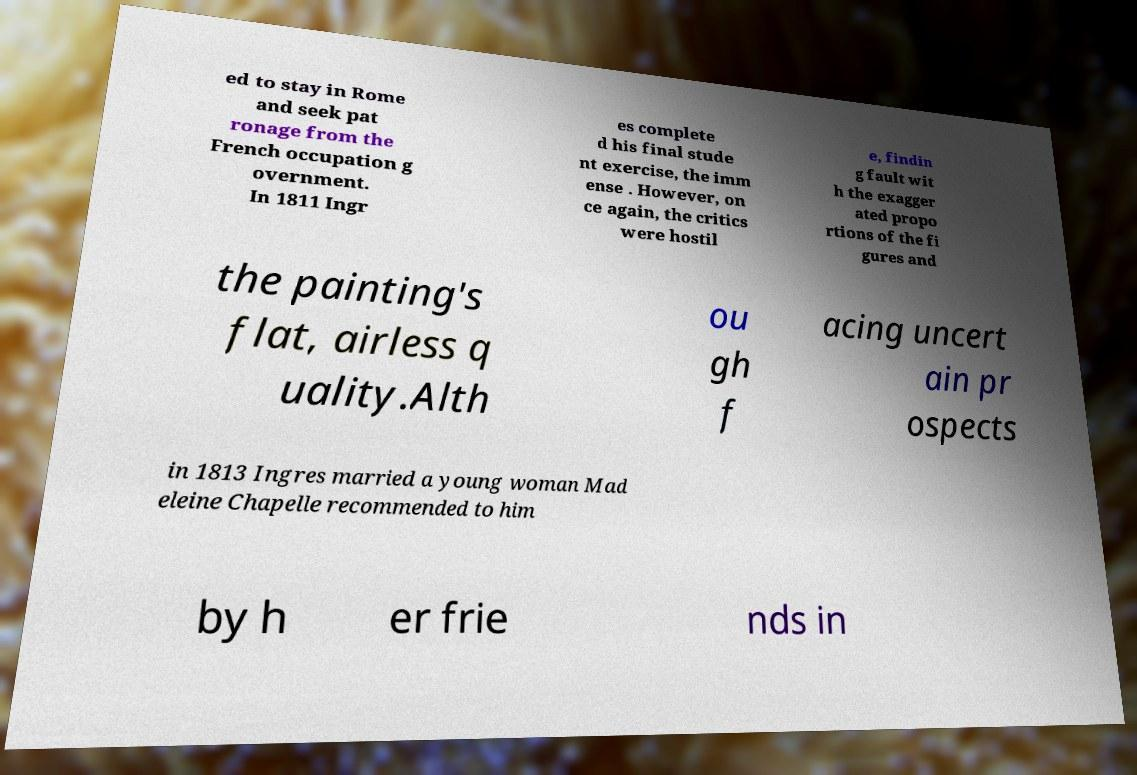Can you accurately transcribe the text from the provided image for me? ed to stay in Rome and seek pat ronage from the French occupation g overnment. In 1811 Ingr es complete d his final stude nt exercise, the imm ense . However, on ce again, the critics were hostil e, findin g fault wit h the exagger ated propo rtions of the fi gures and the painting's flat, airless q uality.Alth ou gh f acing uncert ain pr ospects in 1813 Ingres married a young woman Mad eleine Chapelle recommended to him by h er frie nds in 